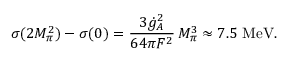Convert formula to latex. <formula><loc_0><loc_0><loc_500><loc_500>\sigma ( 2 M _ { \pi } ^ { 2 } ) - \sigma ( 0 ) = { \frac { 3 \dot { g } _ { A } ^ { 2 } } { 6 4 \pi F ^ { 2 } } } \, M _ { \pi } ^ { 3 } \approx 7 . 5 \ M e V .</formula> 